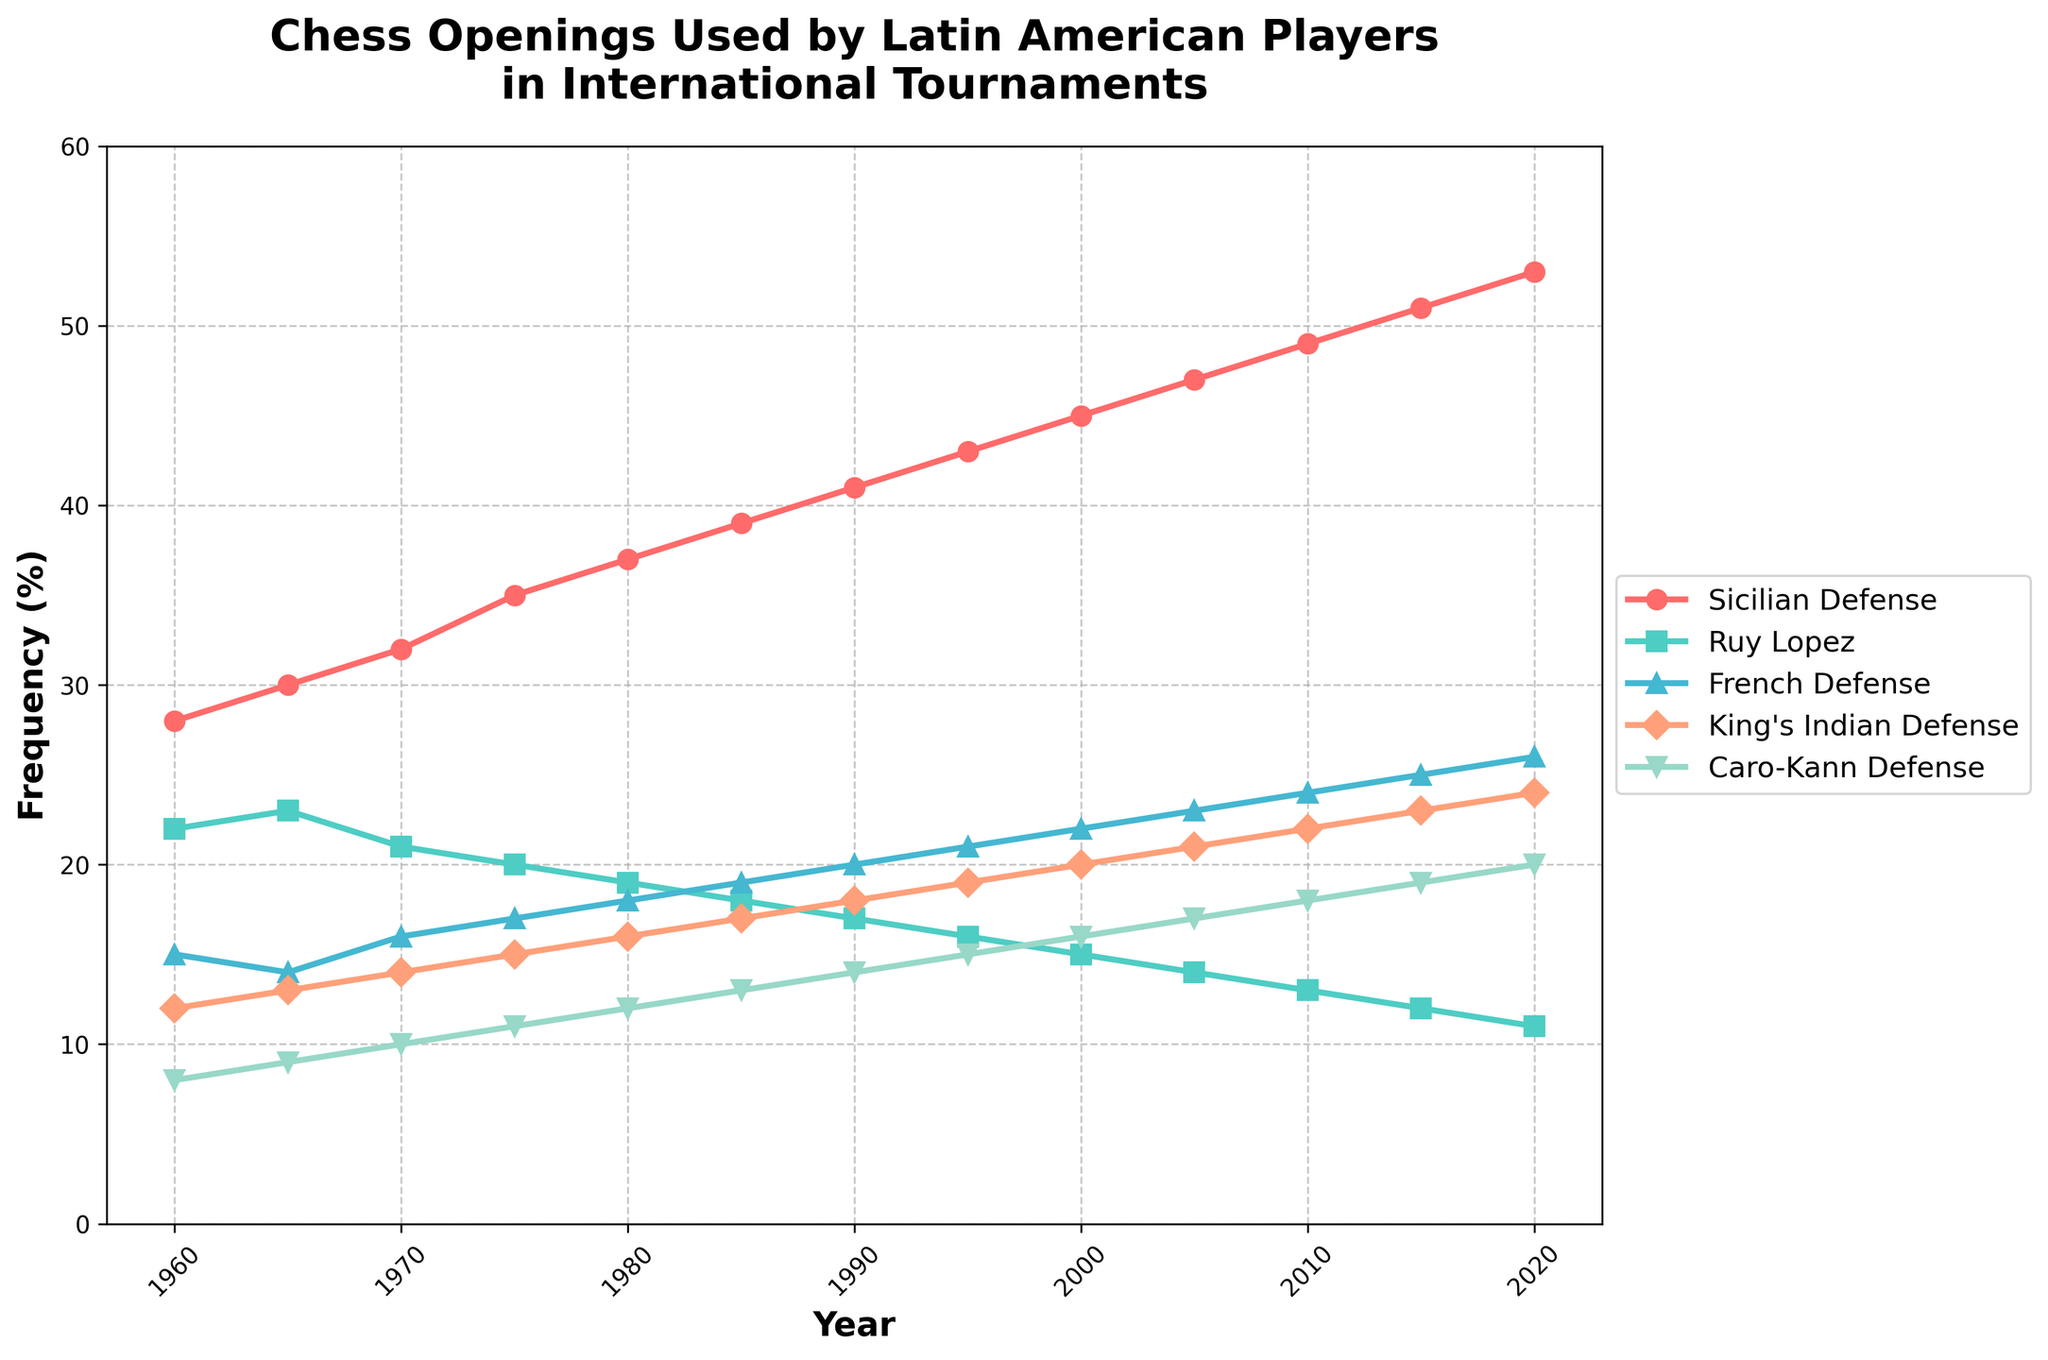Which chess opening was most frequently used by Latin American players in 2020? From the line chart, observe the endpoint in 2020 for each chess opening line. The Sicilian Defense line ends at the highest value of around 53%.
Answer: Sicilian Defense How did the frequency of the Caro-Kann Defense change from 1960 to 2020? Compare the heights of the Caro-Kann Defense line at the two endpoints (1960 and 2020). It started at 8% in 1960 and increased to 20% in 2020.
Answer: Increased by 12% Which opening showed the least change in frequency over the years? Look for the line with the smallest slope across the observed period. The Ruy Lopez line shows a slight steady decrease compared to others with more significant trends.
Answer: Ruy Lopez Between 2000 and 2010, which opening had the highest growth in frequency? Identify the segment between 2000 and 2010 on the x-axis and see which line had the steepest upward slope. The King's Indian Defense line increased from 20% to 22%.
Answer: King's Indian Defense How did the popularity of the French Defense compare to the Ruy Lopez in 1975? Check the relative positions of the French Defense and Ruy Lopez lines at the year 1975. The French Defense was at 17%, and the Ruy Lopez was at 20%.
Answer: French Defense was less popular Calculate the average frequency of the Ruy Lopez between 1960 and 2020. Sum the frequencies of Ruy Lopez at each recorded year (22+23+21+20+19+18+17+16+15+14+13+12+11) and then divide by the number of years (13). The calculation is (222/13) ≈ 17.08%.
Answer: Approximately 17.08% Which year saw all openings at their most balanced state (i.e., the smallest range between the highest and lowest frequencies)? Calculate the difference between the highest and lowest frequencies for each year and determine which year has the smallest difference. In 1970, the range is (32 - 10 = 22) which is the smallest among all.
Answer: 1970 During which decade did the Sicilian Defense see the highest increase in frequency? Compare the increase in the frequencies of the Sicilian Defense line for each decade. The highest increase is from 1965 to 1975, where it jumps from 30% to 35%, an increase of 5%.
Answer: 1965-1975 What was the frequency difference between King's Indian Defense and Caro-Kann Defense in 1985? Note the frequencies for both in 1985 and subtract the values (17% for King's Indian Defense and 13% for Caro-Kann Defense), resulting in (17 - 13 = 4).
Answer: 4% Which two openings were closest in frequency during the year 2005? Compare the frequencies of the openings at the year 2005 and identify the smallest difference. The French Defense and King's Indian Defense are 23% and 21%, respectively, with a difference of 2%.
Answer: French Defense and King's Indian Defense 